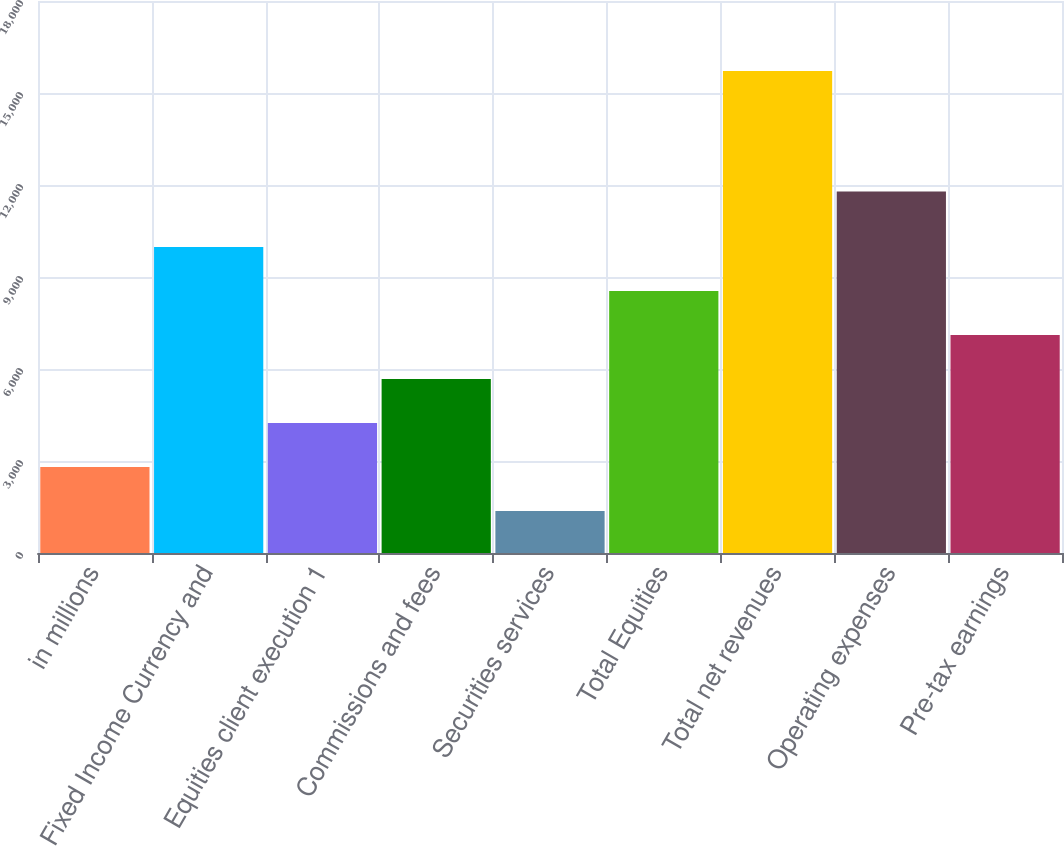Convert chart to OTSL. <chart><loc_0><loc_0><loc_500><loc_500><bar_chart><fcel>in millions<fcel>Fixed Income Currency and<fcel>Equities client execution 1<fcel>Commissions and fees<fcel>Securities services<fcel>Total Equities<fcel>Total net revenues<fcel>Operating expenses<fcel>Pre-tax earnings<nl><fcel>2807.8<fcel>9981.8<fcel>4242.6<fcel>5677.4<fcel>1373<fcel>8547<fcel>15721<fcel>11792<fcel>7112.2<nl></chart> 